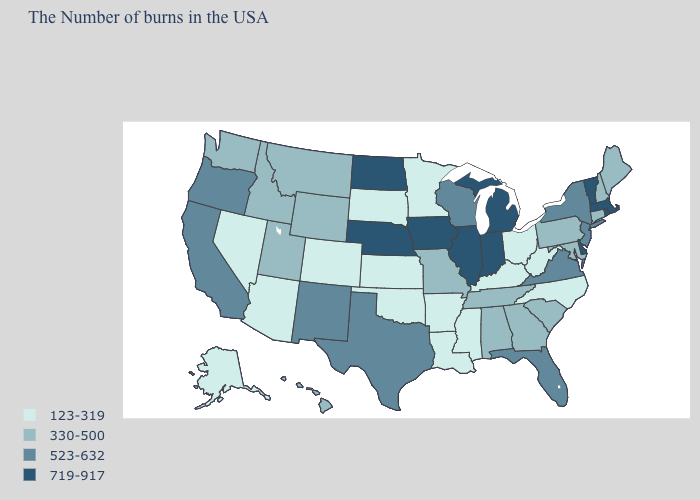Does Wisconsin have the highest value in the MidWest?
Answer briefly. No. Which states hav the highest value in the West?
Short answer required. New Mexico, California, Oregon. Name the states that have a value in the range 123-319?
Write a very short answer. North Carolina, West Virginia, Ohio, Kentucky, Mississippi, Louisiana, Arkansas, Minnesota, Kansas, Oklahoma, South Dakota, Colorado, Arizona, Nevada, Alaska. What is the value of New Mexico?
Keep it brief. 523-632. Among the states that border Arizona , does Colorado have the highest value?
Write a very short answer. No. Does Tennessee have a higher value than Rhode Island?
Give a very brief answer. No. Name the states that have a value in the range 523-632?
Give a very brief answer. New York, New Jersey, Virginia, Florida, Wisconsin, Texas, New Mexico, California, Oregon. What is the highest value in states that border Pennsylvania?
Concise answer only. 719-917. What is the lowest value in the USA?
Concise answer only. 123-319. How many symbols are there in the legend?
Answer briefly. 4. What is the value of Florida?
Concise answer only. 523-632. Which states have the lowest value in the USA?
Write a very short answer. North Carolina, West Virginia, Ohio, Kentucky, Mississippi, Louisiana, Arkansas, Minnesota, Kansas, Oklahoma, South Dakota, Colorado, Arizona, Nevada, Alaska. What is the lowest value in the West?
Short answer required. 123-319. How many symbols are there in the legend?
Quick response, please. 4. Name the states that have a value in the range 719-917?
Concise answer only. Massachusetts, Rhode Island, Vermont, Delaware, Michigan, Indiana, Illinois, Iowa, Nebraska, North Dakota. 